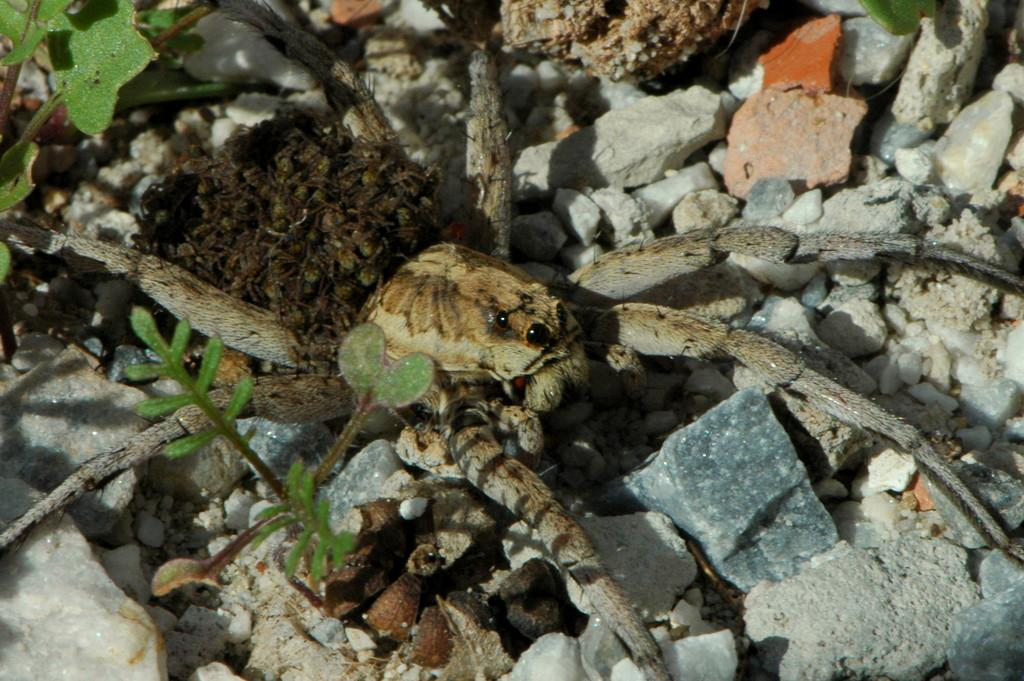What is the main subject of the image? There is a spider in the image. Can you describe the appearance of the spider? The spider is brown, cream, and black in color. What is the spider's location in the image? The spider is on a rocky surface. What type of vegetation is present in the image? There are green plants in the image. What other objects can be seen in the image? There are stones in the image. Is the queen present in the image? There is no queen depicted in the image; it features a spider on a rocky surface. Can you tell me how many ladybugs in the image are supporting the spider? There are no ladybugs or any other creatures present in the image to support the spider. 